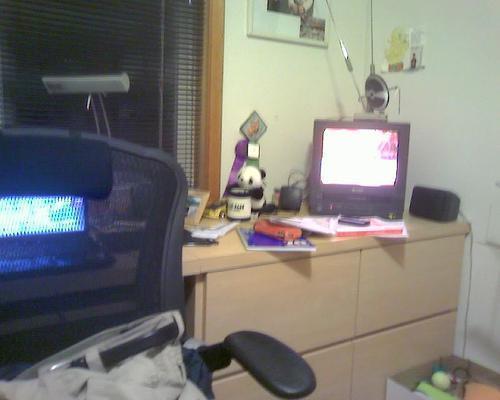How many chairs are there?
Give a very brief answer. 2. 